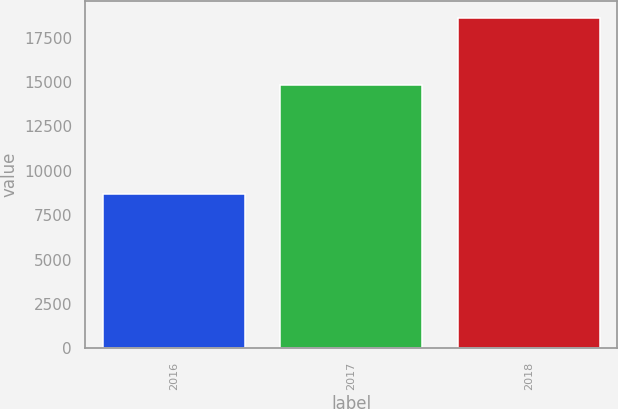Convert chart. <chart><loc_0><loc_0><loc_500><loc_500><bar_chart><fcel>2016<fcel>2017<fcel>2018<nl><fcel>8705<fcel>14826<fcel>18625<nl></chart> 